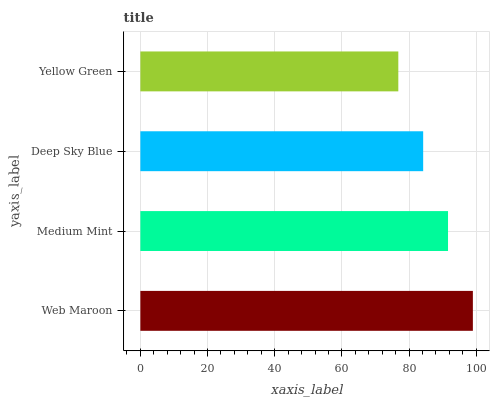Is Yellow Green the minimum?
Answer yes or no. Yes. Is Web Maroon the maximum?
Answer yes or no. Yes. Is Medium Mint the minimum?
Answer yes or no. No. Is Medium Mint the maximum?
Answer yes or no. No. Is Web Maroon greater than Medium Mint?
Answer yes or no. Yes. Is Medium Mint less than Web Maroon?
Answer yes or no. Yes. Is Medium Mint greater than Web Maroon?
Answer yes or no. No. Is Web Maroon less than Medium Mint?
Answer yes or no. No. Is Medium Mint the high median?
Answer yes or no. Yes. Is Deep Sky Blue the low median?
Answer yes or no. Yes. Is Deep Sky Blue the high median?
Answer yes or no. No. Is Web Maroon the low median?
Answer yes or no. No. 